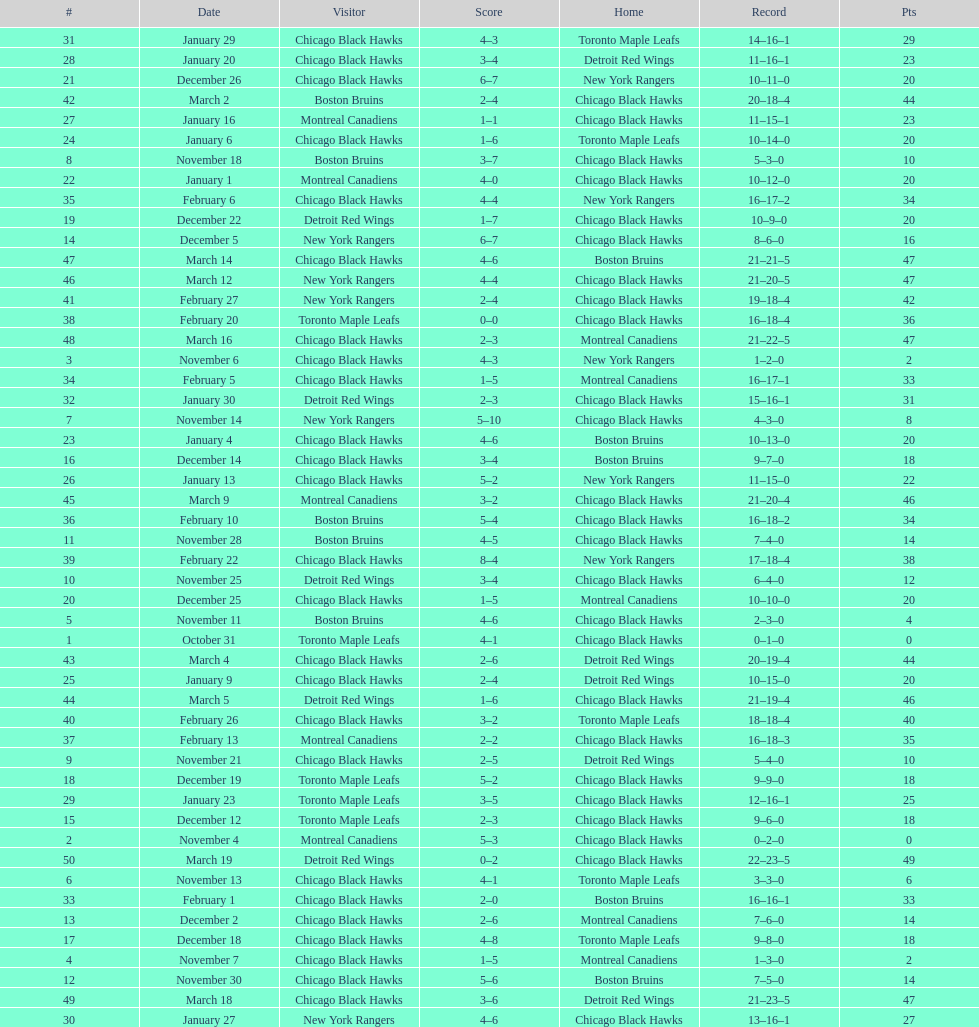What was the total amount of points scored on november 4th? 8. 